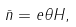Convert formula to latex. <formula><loc_0><loc_0><loc_500><loc_500>\bar { n } = e \theta H ,</formula> 